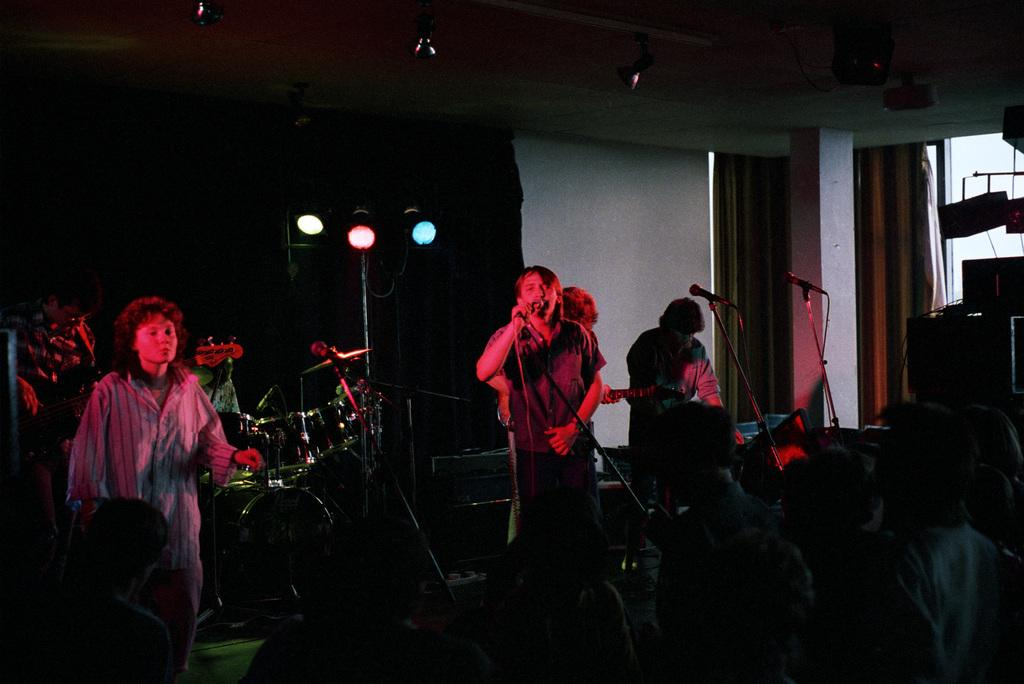What are the people in the image doing? The people in the image are standing and watching a man playing drums. What is the man in the image doing? The man in the image is playing drums. What might the people be enjoying or observing in the image? The people are likely enjoying or observing the man playing drums. How many clams are visible in the image? There are no clams present in the image. What type of flock is flying in the background of the image? There is no flock visible in the image; it only features people and a man playing drums. 